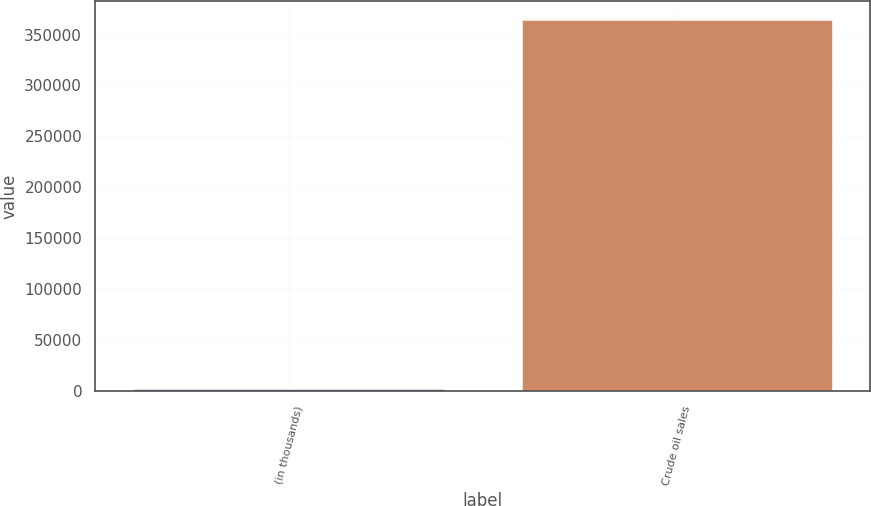<chart> <loc_0><loc_0><loc_500><loc_500><bar_chart><fcel>(in thousands)<fcel>Crude oil sales<nl><fcel>2003<fcel>364382<nl></chart> 